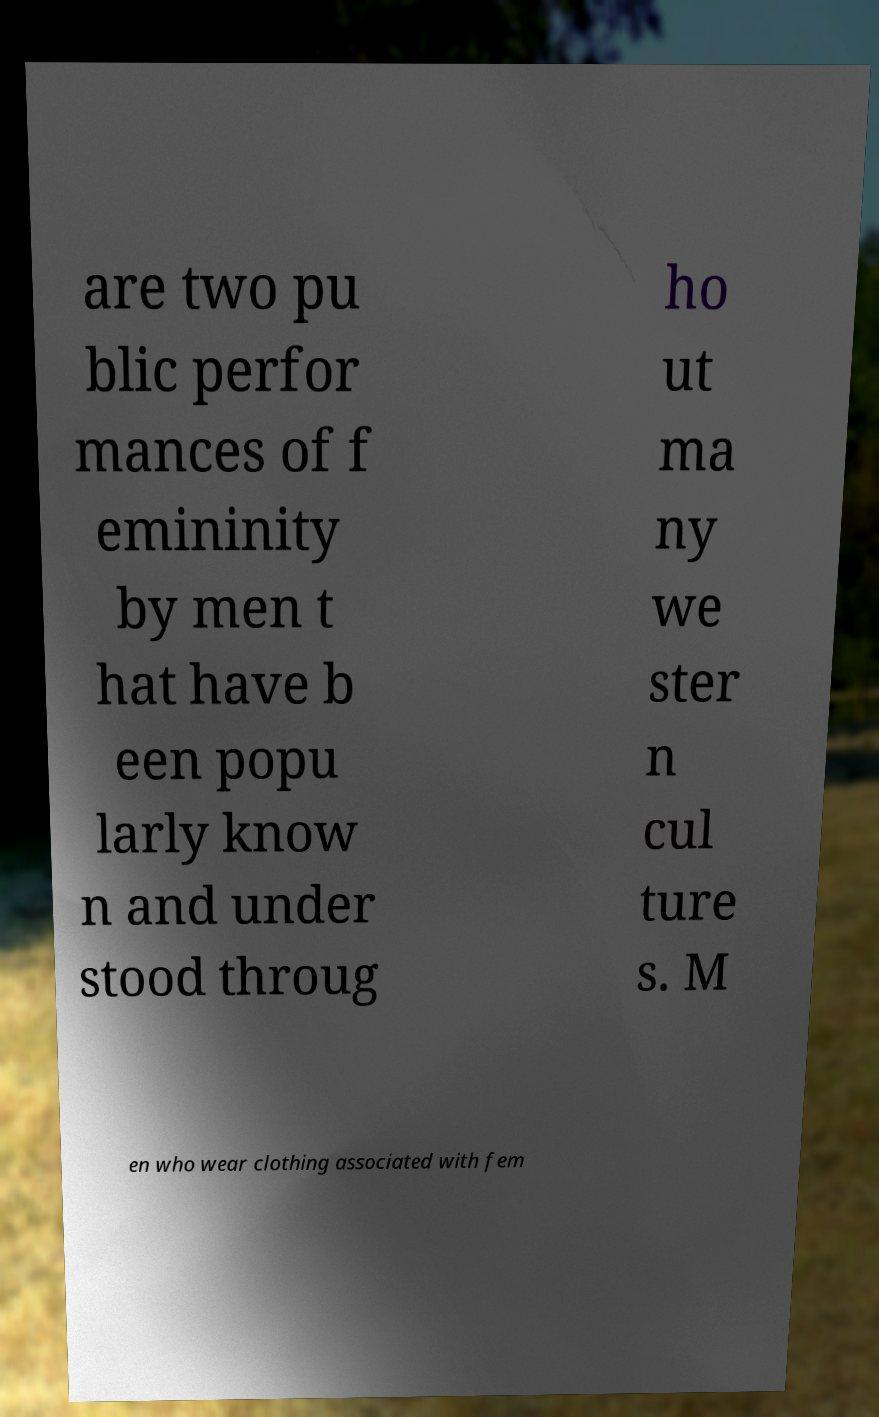I need the written content from this picture converted into text. Can you do that? are two pu blic perfor mances of f emininity by men t hat have b een popu larly know n and under stood throug ho ut ma ny we ster n cul ture s. M en who wear clothing associated with fem 